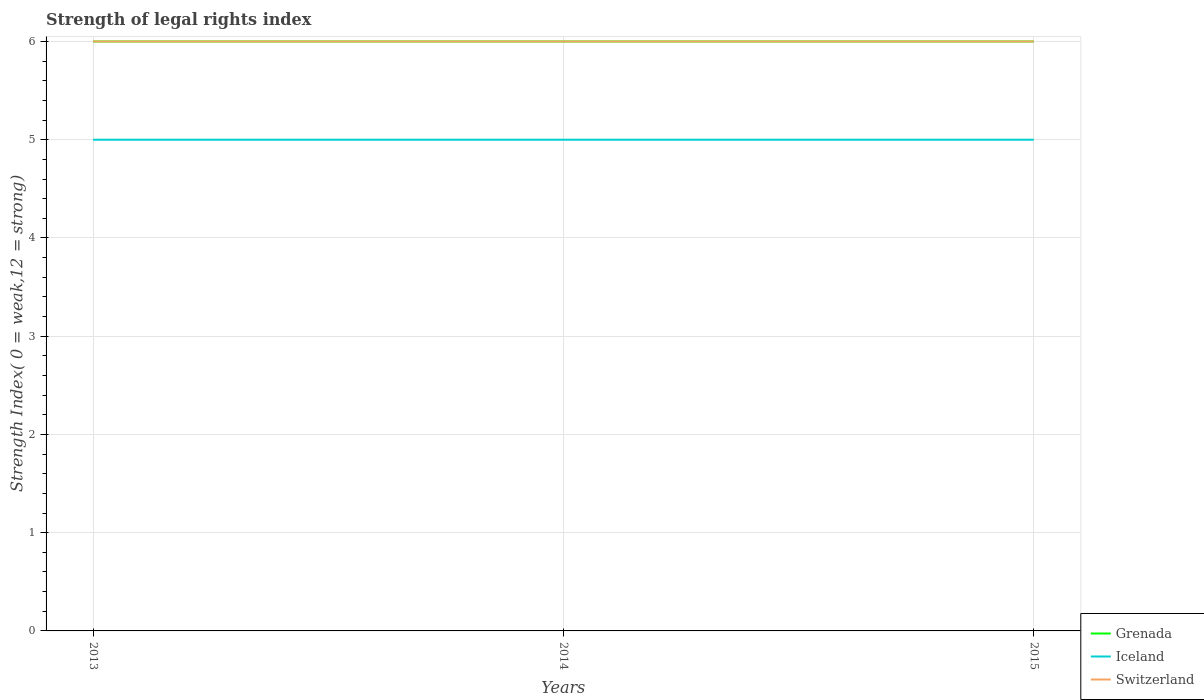Is the number of lines equal to the number of legend labels?
Give a very brief answer. Yes. Across all years, what is the maximum strength index in Switzerland?
Provide a short and direct response. 6. What is the total strength index in Switzerland in the graph?
Offer a terse response. 0. What is the difference between the highest and the second highest strength index in Switzerland?
Your answer should be very brief. 0. Is the strength index in Grenada strictly greater than the strength index in Iceland over the years?
Your answer should be very brief. No. How many years are there in the graph?
Provide a succinct answer. 3. What is the difference between two consecutive major ticks on the Y-axis?
Offer a terse response. 1. Does the graph contain any zero values?
Offer a very short reply. No. Where does the legend appear in the graph?
Give a very brief answer. Bottom right. How many legend labels are there?
Make the answer very short. 3. What is the title of the graph?
Provide a succinct answer. Strength of legal rights index. What is the label or title of the X-axis?
Provide a short and direct response. Years. What is the label or title of the Y-axis?
Give a very brief answer. Strength Index( 0 = weak,12 = strong). What is the Strength Index( 0 = weak,12 = strong) of Grenada in 2013?
Provide a short and direct response. 6. What is the Strength Index( 0 = weak,12 = strong) of Iceland in 2013?
Offer a terse response. 5. What is the Strength Index( 0 = weak,12 = strong) of Iceland in 2014?
Provide a short and direct response. 5. Across all years, what is the maximum Strength Index( 0 = weak,12 = strong) of Grenada?
Give a very brief answer. 6. Across all years, what is the maximum Strength Index( 0 = weak,12 = strong) in Iceland?
Your answer should be compact. 5. Across all years, what is the maximum Strength Index( 0 = weak,12 = strong) in Switzerland?
Your answer should be compact. 6. What is the total Strength Index( 0 = weak,12 = strong) of Grenada in the graph?
Your response must be concise. 18. What is the total Strength Index( 0 = weak,12 = strong) of Iceland in the graph?
Your response must be concise. 15. What is the difference between the Strength Index( 0 = weak,12 = strong) of Switzerland in 2013 and that in 2014?
Provide a short and direct response. 0. What is the difference between the Strength Index( 0 = weak,12 = strong) in Grenada in 2013 and that in 2015?
Your answer should be very brief. 0. What is the difference between the Strength Index( 0 = weak,12 = strong) of Iceland in 2013 and that in 2015?
Give a very brief answer. 0. What is the difference between the Strength Index( 0 = weak,12 = strong) in Switzerland in 2013 and that in 2015?
Your response must be concise. 0. What is the difference between the Strength Index( 0 = weak,12 = strong) in Grenada in 2013 and the Strength Index( 0 = weak,12 = strong) in Iceland in 2015?
Your answer should be very brief. 1. What is the difference between the Strength Index( 0 = weak,12 = strong) of Grenada in 2013 and the Strength Index( 0 = weak,12 = strong) of Switzerland in 2015?
Your answer should be very brief. 0. What is the difference between the Strength Index( 0 = weak,12 = strong) of Iceland in 2013 and the Strength Index( 0 = weak,12 = strong) of Switzerland in 2015?
Your answer should be compact. -1. What is the difference between the Strength Index( 0 = weak,12 = strong) in Grenada in 2014 and the Strength Index( 0 = weak,12 = strong) in Iceland in 2015?
Provide a succinct answer. 1. In the year 2013, what is the difference between the Strength Index( 0 = weak,12 = strong) of Grenada and Strength Index( 0 = weak,12 = strong) of Iceland?
Your answer should be compact. 1. In the year 2014, what is the difference between the Strength Index( 0 = weak,12 = strong) in Grenada and Strength Index( 0 = weak,12 = strong) in Iceland?
Make the answer very short. 1. In the year 2015, what is the difference between the Strength Index( 0 = weak,12 = strong) of Grenada and Strength Index( 0 = weak,12 = strong) of Iceland?
Offer a very short reply. 1. In the year 2015, what is the difference between the Strength Index( 0 = weak,12 = strong) of Iceland and Strength Index( 0 = weak,12 = strong) of Switzerland?
Keep it short and to the point. -1. What is the ratio of the Strength Index( 0 = weak,12 = strong) in Grenada in 2013 to that in 2014?
Make the answer very short. 1. What is the ratio of the Strength Index( 0 = weak,12 = strong) in Switzerland in 2013 to that in 2014?
Your answer should be very brief. 1. What is the ratio of the Strength Index( 0 = weak,12 = strong) in Iceland in 2013 to that in 2015?
Your answer should be compact. 1. What is the difference between the highest and the second highest Strength Index( 0 = weak,12 = strong) of Iceland?
Ensure brevity in your answer.  0. What is the difference between the highest and the second highest Strength Index( 0 = weak,12 = strong) of Switzerland?
Offer a very short reply. 0. What is the difference between the highest and the lowest Strength Index( 0 = weak,12 = strong) in Grenada?
Ensure brevity in your answer.  0. What is the difference between the highest and the lowest Strength Index( 0 = weak,12 = strong) of Iceland?
Ensure brevity in your answer.  0. 